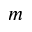Convert formula to latex. <formula><loc_0><loc_0><loc_500><loc_500>m</formula> 